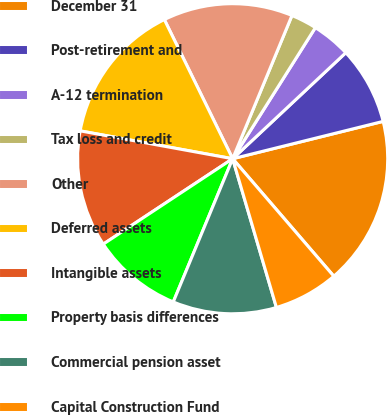Convert chart to OTSL. <chart><loc_0><loc_0><loc_500><loc_500><pie_chart><fcel>December 31<fcel>Post-retirement and<fcel>A-12 termination<fcel>Tax loss and credit<fcel>Other<fcel>Deferred assets<fcel>Intangible assets<fcel>Property basis differences<fcel>Commercial pension asset<fcel>Capital Construction Fund<nl><fcel>17.56%<fcel>8.11%<fcel>4.06%<fcel>2.71%<fcel>13.51%<fcel>14.86%<fcel>12.16%<fcel>9.46%<fcel>10.81%<fcel>6.76%<nl></chart> 